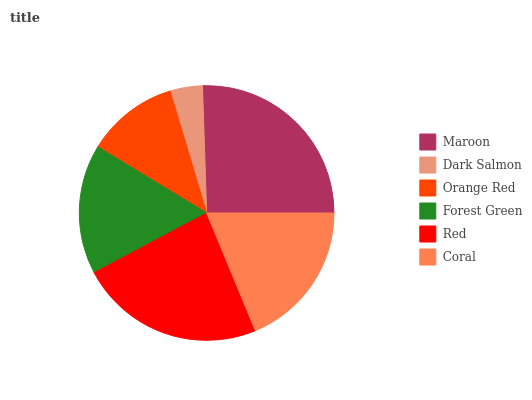Is Dark Salmon the minimum?
Answer yes or no. Yes. Is Maroon the maximum?
Answer yes or no. Yes. Is Orange Red the minimum?
Answer yes or no. No. Is Orange Red the maximum?
Answer yes or no. No. Is Orange Red greater than Dark Salmon?
Answer yes or no. Yes. Is Dark Salmon less than Orange Red?
Answer yes or no. Yes. Is Dark Salmon greater than Orange Red?
Answer yes or no. No. Is Orange Red less than Dark Salmon?
Answer yes or no. No. Is Coral the high median?
Answer yes or no. Yes. Is Forest Green the low median?
Answer yes or no. Yes. Is Red the high median?
Answer yes or no. No. Is Red the low median?
Answer yes or no. No. 